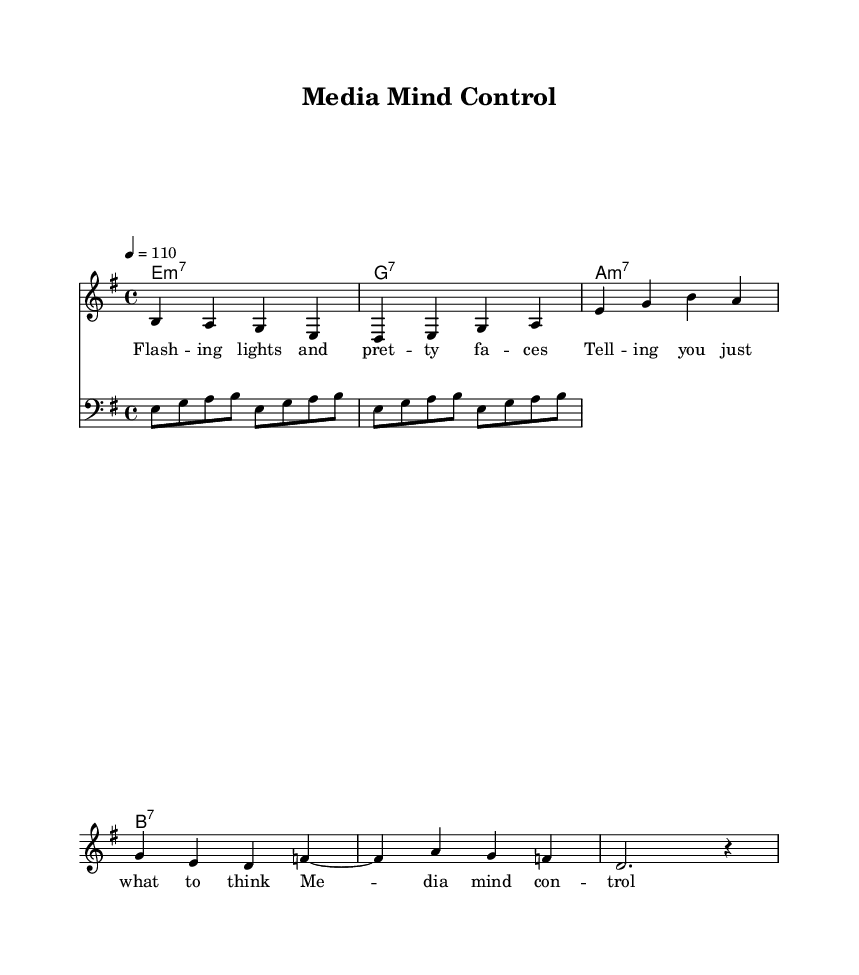What is the key signature of this music? The key signature is E minor, indicated by one sharp (F#) at the beginning of the staff.
Answer: E minor What is the time signature of the piece? The time signature shown in the music is 4/4, which is typically indicated at the beginning where you see the "4 over 4" symbol.
Answer: 4/4 What is the tempo of the piece? The tempo marking at the beginning indicates the piece should be played at 110 beats per minute.
Answer: 110 How many measures are in the verse? By counting the notation in the verse section, there are 4 measures represented by the horizontal lines with notes beneath them.
Answer: 4 Which chord appears first in the chord progression? The chord progression starts with E minor 7, which is shown first in the chord names above the melody.
Answer: E minor 7 What is the thematic focus of the lyrics? The lyrics critique the media influence on people's perceptions, as indicated by phrases like "Media mind control" and "selling you a role."
Answer: Media influence What type of guitar chords are used in the progression? The chords in the progression include a mix of minor and dominant seventh chords, specifically E minor 7 and G7 among others.
Answer: Minor and dominant seventh 